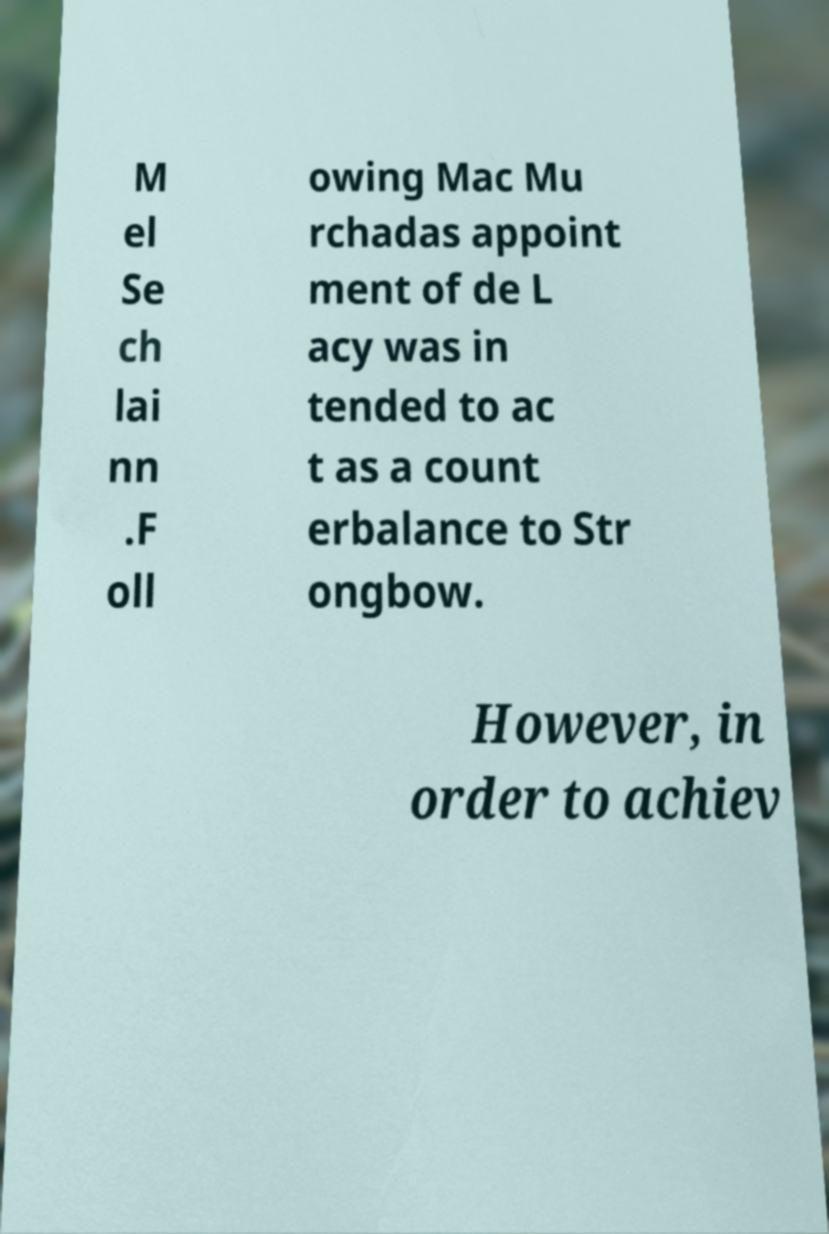There's text embedded in this image that I need extracted. Can you transcribe it verbatim? M el Se ch lai nn .F oll owing Mac Mu rchadas appoint ment of de L acy was in tended to ac t as a count erbalance to Str ongbow. However, in order to achiev 